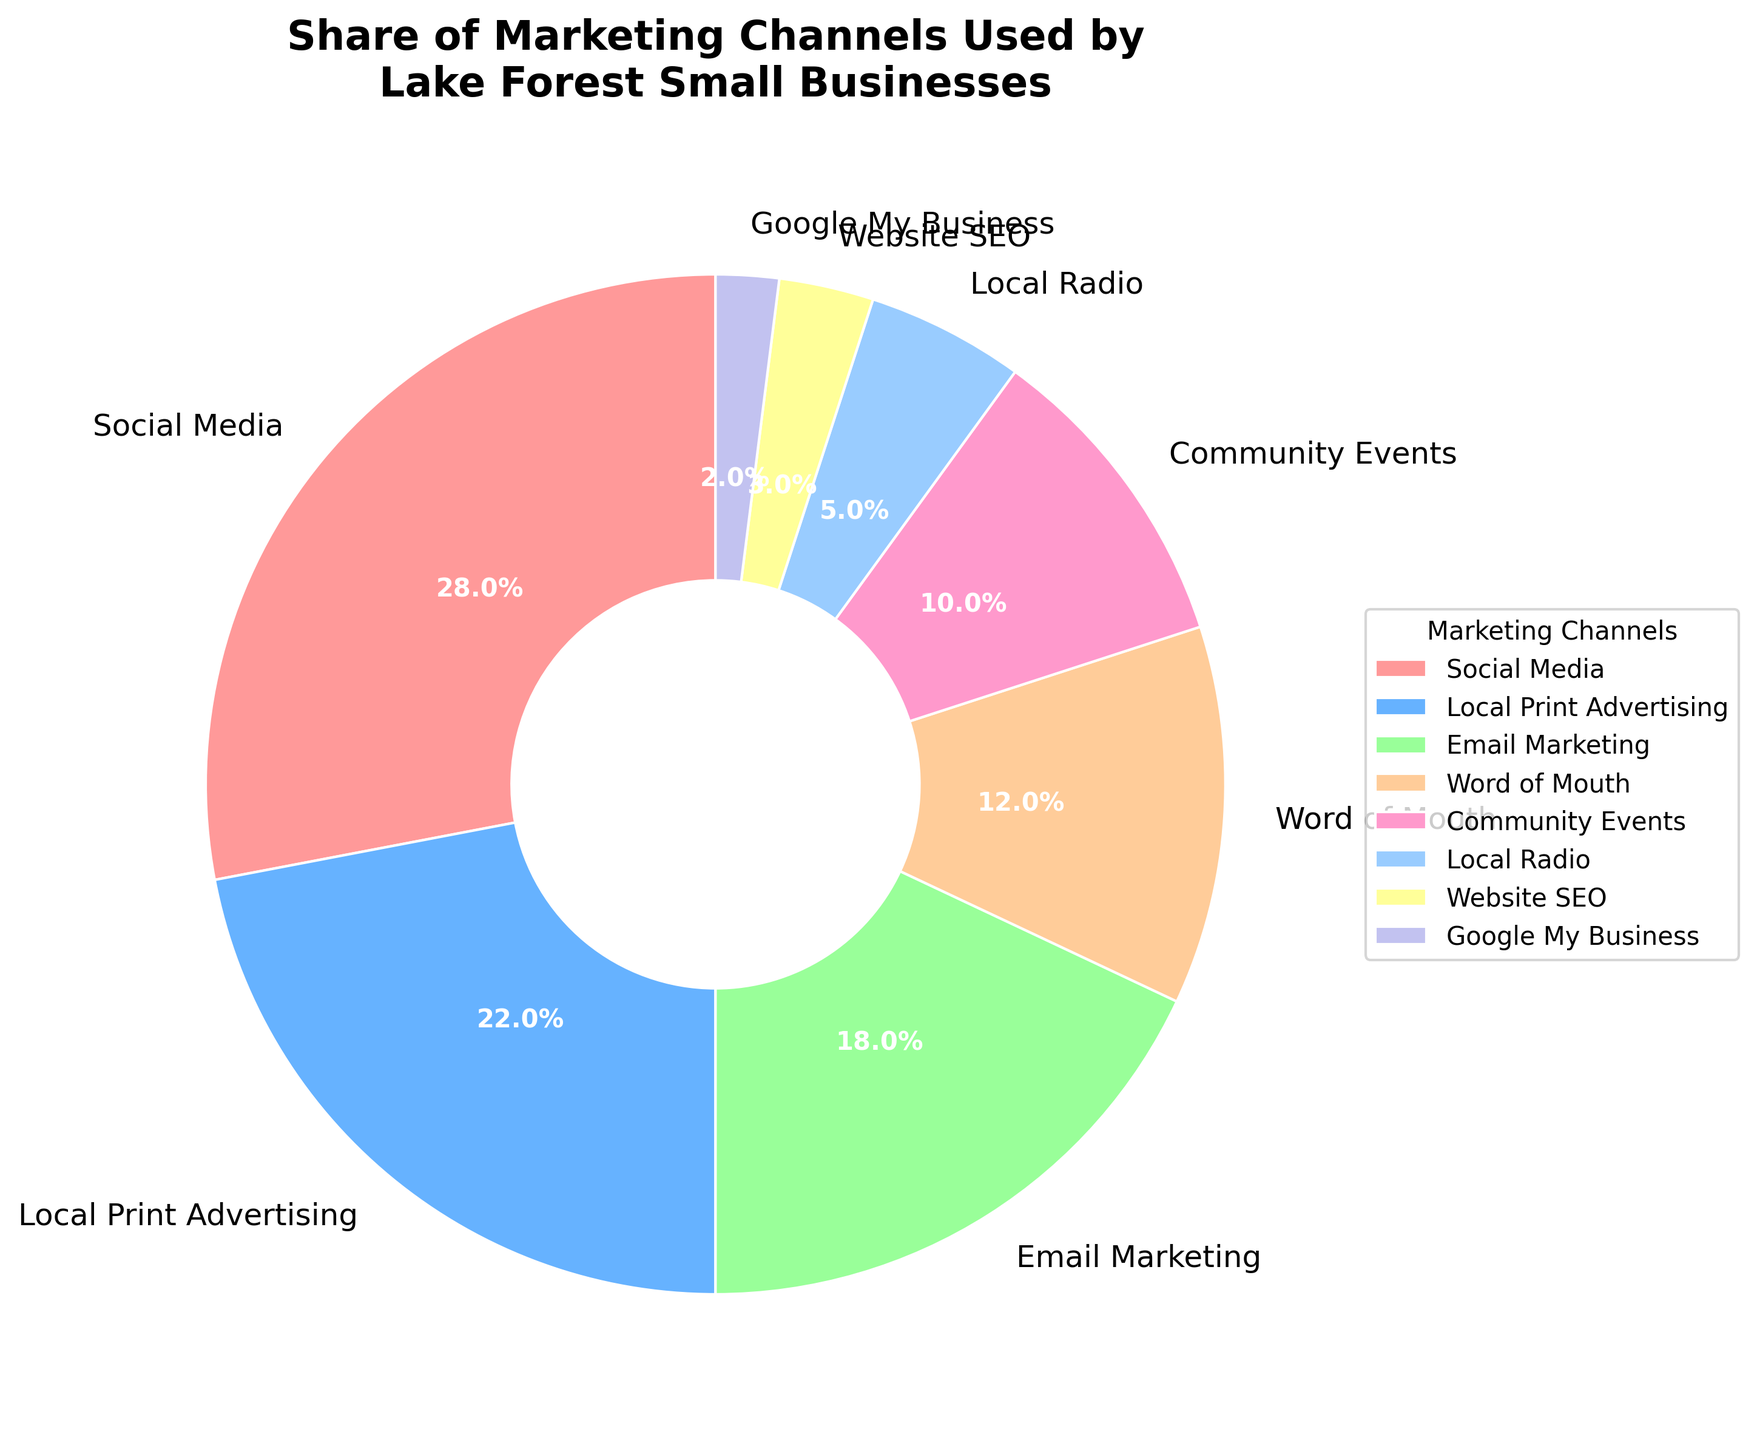What's the largest marketing channel used by Lake Forest small businesses? To determine the largest marketing channel, look at the section with the greatest percentage value on the pie chart.
Answer: Social Media What is the combined percentage of Local Print Advertising and Email Marketing? Add the percentage values of Local Print Advertising (22%) and Email Marketing (18%). The sum is 22% + 18% = 40%.
Answer: 40% How much larger is the percentage of Word of Mouth compared to Local Radio? Subtract the percentage of Local Radio (5%) from Word of Mouth (12%). 12% - 5% = 7%.
Answer: 7% Which marketing channel has the smallest share? Identify the section with the smallest percentage value on the pie chart.
Answer: Google My Business What is the difference in percentage between the highest and lowest marketing channels? Subtract the percentage of Google My Business (2%) from Social Media (28%). 28% - 2% = 26%.
Answer: 26% What proportion of the marketing channels is allocated to community-focused strategies (Community Events and Word of Mouth)? Add the percentages of Community Events (10%) and Word of Mouth (12%). 10% + 12% = 22%.
Answer: 22% Which marketing channel is represented by the blue color? Look at the pie chart and identify the marketing channel associated with the blue section.
Answer: Local Print Advertising How many marketing channels have a percentage equal to or greater than Email Marketing? Count the sections with percentages equal to or greater than 18% (Email Marketing: 18%, Local Print Advertising: 22%, Social Media: 28%). There are three sections.
Answer: 3 What is the average percentage of the bottom three marketing channels (Website SEO, Google My Business, Local Radio)? Sum the percentages of Website SEO (3%), Google My Business (2%), and Local Radio (5%), then divide by 3. (3% + 2% + 5%) / 3 = 3.33%.
Answer: 3.33% 